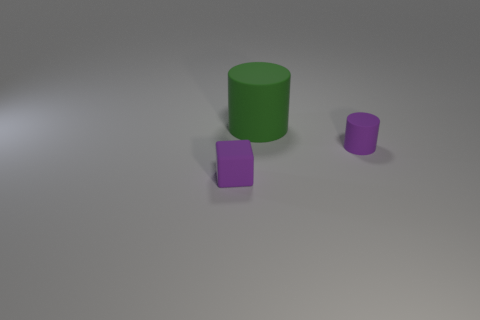Are there any other things that are the same size as the green matte cylinder?
Provide a succinct answer. No. The large green object has what shape?
Your answer should be very brief. Cylinder. How many tiny rubber objects are right of the tiny purple thing that is to the left of the purple rubber thing to the right of the tiny purple rubber block?
Make the answer very short. 1. There is a purple thing that is to the left of the rubber cylinder that is behind the small matte object behind the tiny purple cube; what is its shape?
Offer a very short reply. Cube. There is a rubber thing that is left of the small cylinder and behind the purple cube; what size is it?
Provide a succinct answer. Large. Is the number of purple matte cylinders less than the number of yellow rubber cylinders?
Make the answer very short. No. How big is the object to the right of the big green matte cylinder?
Provide a succinct answer. Small. The rubber thing that is right of the purple rubber cube and in front of the large green rubber thing has what shape?
Offer a terse response. Cylinder. There is another purple thing that is the same shape as the large matte thing; what size is it?
Offer a very short reply. Small. What number of other small purple cubes are the same material as the purple cube?
Provide a short and direct response. 0. 